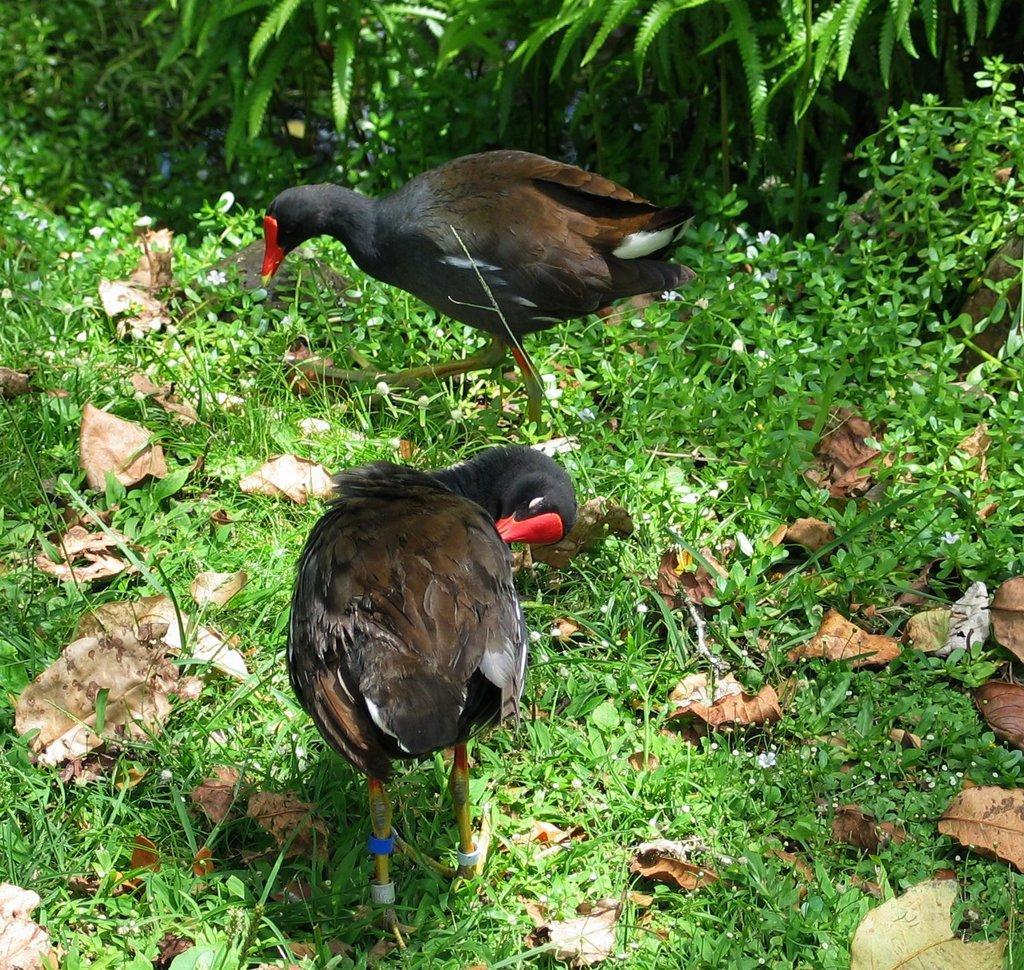How would you summarize this image in a sentence or two? In the image we can see two birds, dry leaves, grass and plants. 